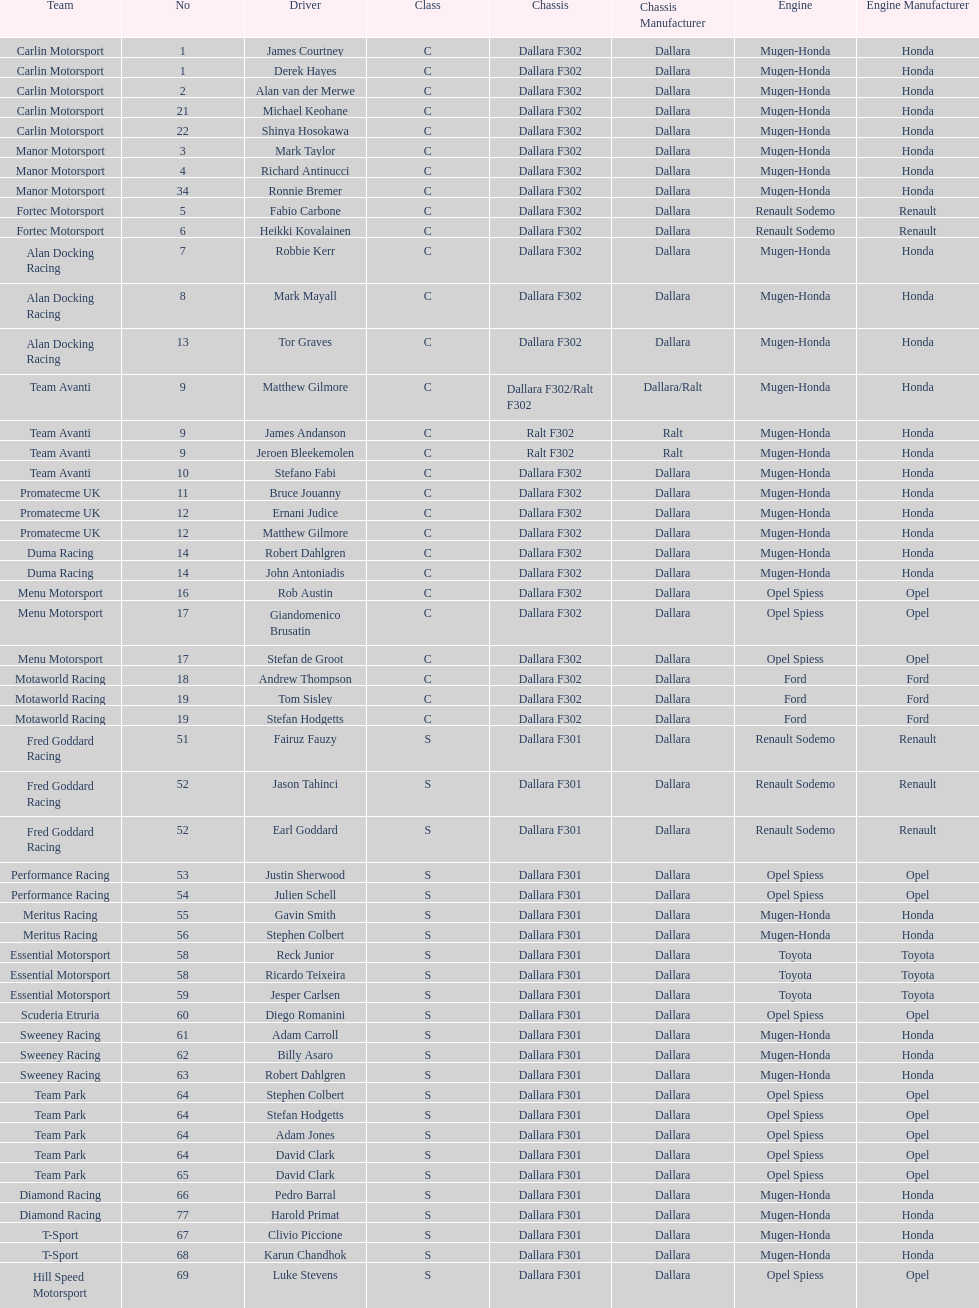What is the average number of teams that had a mugen-honda engine? 24. 